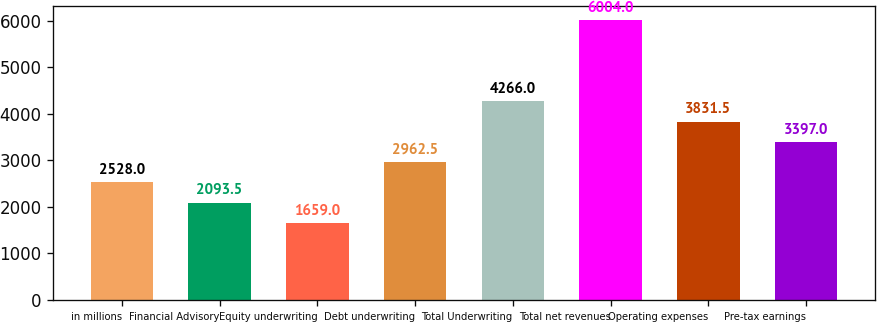<chart> <loc_0><loc_0><loc_500><loc_500><bar_chart><fcel>in millions<fcel>Financial Advisory<fcel>Equity underwriting<fcel>Debt underwriting<fcel>Total Underwriting<fcel>Total net revenues<fcel>Operating expenses<fcel>Pre-tax earnings<nl><fcel>2528<fcel>2093.5<fcel>1659<fcel>2962.5<fcel>4266<fcel>6004<fcel>3831.5<fcel>3397<nl></chart> 